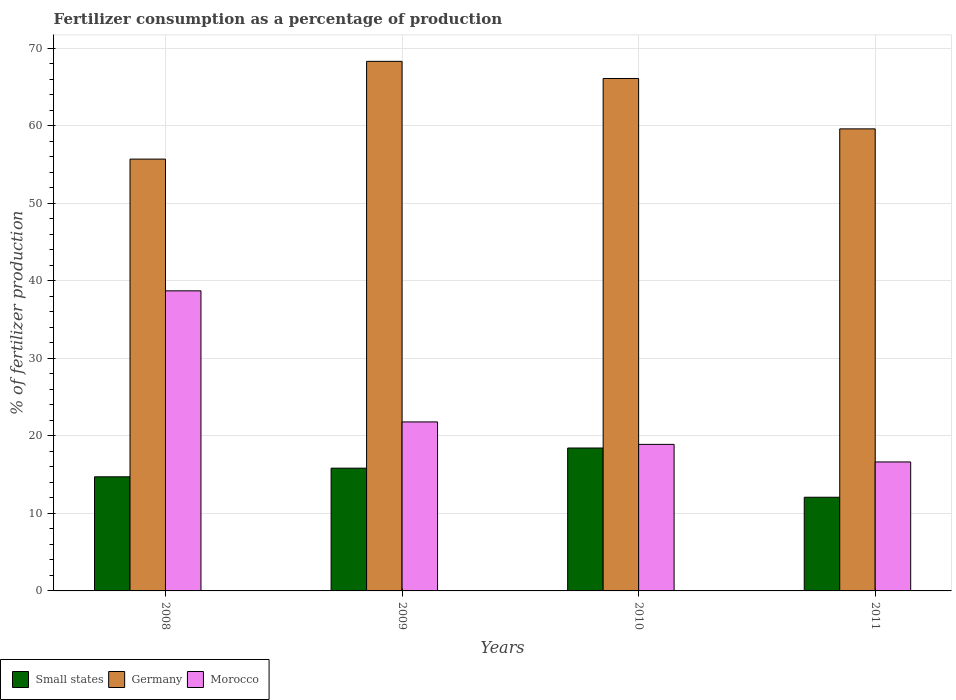Are the number of bars per tick equal to the number of legend labels?
Ensure brevity in your answer.  Yes. How many bars are there on the 4th tick from the left?
Your answer should be very brief. 3. What is the label of the 2nd group of bars from the left?
Your response must be concise. 2009. In how many cases, is the number of bars for a given year not equal to the number of legend labels?
Your response must be concise. 0. What is the percentage of fertilizers consumed in Germany in 2011?
Offer a very short reply. 59.58. Across all years, what is the maximum percentage of fertilizers consumed in Small states?
Keep it short and to the point. 18.43. Across all years, what is the minimum percentage of fertilizers consumed in Germany?
Give a very brief answer. 55.68. In which year was the percentage of fertilizers consumed in Morocco minimum?
Give a very brief answer. 2011. What is the total percentage of fertilizers consumed in Small states in the graph?
Keep it short and to the point. 61.05. What is the difference between the percentage of fertilizers consumed in Small states in 2009 and that in 2010?
Keep it short and to the point. -2.6. What is the difference between the percentage of fertilizers consumed in Morocco in 2008 and the percentage of fertilizers consumed in Germany in 2010?
Your answer should be compact. -27.38. What is the average percentage of fertilizers consumed in Morocco per year?
Your response must be concise. 24. In the year 2010, what is the difference between the percentage of fertilizers consumed in Germany and percentage of fertilizers consumed in Morocco?
Your answer should be compact. 47.18. In how many years, is the percentage of fertilizers consumed in Morocco greater than 44 %?
Offer a very short reply. 0. What is the ratio of the percentage of fertilizers consumed in Morocco in 2008 to that in 2011?
Offer a terse response. 2.33. Is the percentage of fertilizers consumed in Morocco in 2008 less than that in 2009?
Ensure brevity in your answer.  No. What is the difference between the highest and the second highest percentage of fertilizers consumed in Small states?
Keep it short and to the point. 2.6. What is the difference between the highest and the lowest percentage of fertilizers consumed in Morocco?
Make the answer very short. 22.06. In how many years, is the percentage of fertilizers consumed in Small states greater than the average percentage of fertilizers consumed in Small states taken over all years?
Your answer should be very brief. 2. What does the 3rd bar from the left in 2009 represents?
Offer a very short reply. Morocco. What does the 1st bar from the right in 2009 represents?
Your answer should be compact. Morocco. How many bars are there?
Provide a succinct answer. 12. What is the difference between two consecutive major ticks on the Y-axis?
Make the answer very short. 10. Are the values on the major ticks of Y-axis written in scientific E-notation?
Keep it short and to the point. No. How are the legend labels stacked?
Provide a short and direct response. Horizontal. What is the title of the graph?
Keep it short and to the point. Fertilizer consumption as a percentage of production. Does "Seychelles" appear as one of the legend labels in the graph?
Offer a terse response. No. What is the label or title of the X-axis?
Provide a short and direct response. Years. What is the label or title of the Y-axis?
Provide a succinct answer. % of fertilizer production. What is the % of fertilizer production of Small states in 2008?
Provide a short and direct response. 14.71. What is the % of fertilizer production in Germany in 2008?
Make the answer very short. 55.68. What is the % of fertilizer production in Morocco in 2008?
Your answer should be very brief. 38.69. What is the % of fertilizer production of Small states in 2009?
Your response must be concise. 15.83. What is the % of fertilizer production of Germany in 2009?
Provide a short and direct response. 68.28. What is the % of fertilizer production in Morocco in 2009?
Provide a short and direct response. 21.79. What is the % of fertilizer production in Small states in 2010?
Your answer should be very brief. 18.43. What is the % of fertilizer production of Germany in 2010?
Your response must be concise. 66.07. What is the % of fertilizer production in Morocco in 2010?
Your answer should be compact. 18.9. What is the % of fertilizer production of Small states in 2011?
Keep it short and to the point. 12.08. What is the % of fertilizer production in Germany in 2011?
Give a very brief answer. 59.58. What is the % of fertilizer production of Morocco in 2011?
Your answer should be very brief. 16.63. Across all years, what is the maximum % of fertilizer production of Small states?
Give a very brief answer. 18.43. Across all years, what is the maximum % of fertilizer production in Germany?
Provide a short and direct response. 68.28. Across all years, what is the maximum % of fertilizer production of Morocco?
Provide a short and direct response. 38.69. Across all years, what is the minimum % of fertilizer production of Small states?
Provide a succinct answer. 12.08. Across all years, what is the minimum % of fertilizer production of Germany?
Offer a very short reply. 55.68. Across all years, what is the minimum % of fertilizer production of Morocco?
Make the answer very short. 16.63. What is the total % of fertilizer production in Small states in the graph?
Provide a succinct answer. 61.05. What is the total % of fertilizer production of Germany in the graph?
Make the answer very short. 249.61. What is the total % of fertilizer production of Morocco in the graph?
Provide a succinct answer. 96.01. What is the difference between the % of fertilizer production of Small states in 2008 and that in 2009?
Make the answer very short. -1.11. What is the difference between the % of fertilizer production of Germany in 2008 and that in 2009?
Offer a terse response. -12.6. What is the difference between the % of fertilizer production in Morocco in 2008 and that in 2009?
Your answer should be very brief. 16.9. What is the difference between the % of fertilizer production of Small states in 2008 and that in 2010?
Offer a terse response. -3.71. What is the difference between the % of fertilizer production in Germany in 2008 and that in 2010?
Your response must be concise. -10.39. What is the difference between the % of fertilizer production in Morocco in 2008 and that in 2010?
Your answer should be very brief. 19.8. What is the difference between the % of fertilizer production in Small states in 2008 and that in 2011?
Your answer should be compact. 2.64. What is the difference between the % of fertilizer production of Germany in 2008 and that in 2011?
Your answer should be compact. -3.9. What is the difference between the % of fertilizer production of Morocco in 2008 and that in 2011?
Ensure brevity in your answer.  22.06. What is the difference between the % of fertilizer production in Small states in 2009 and that in 2010?
Your answer should be very brief. -2.6. What is the difference between the % of fertilizer production of Germany in 2009 and that in 2010?
Your answer should be compact. 2.21. What is the difference between the % of fertilizer production in Morocco in 2009 and that in 2010?
Give a very brief answer. 2.9. What is the difference between the % of fertilizer production in Small states in 2009 and that in 2011?
Provide a short and direct response. 3.75. What is the difference between the % of fertilizer production of Germany in 2009 and that in 2011?
Make the answer very short. 8.7. What is the difference between the % of fertilizer production in Morocco in 2009 and that in 2011?
Give a very brief answer. 5.16. What is the difference between the % of fertilizer production of Small states in 2010 and that in 2011?
Offer a very short reply. 6.35. What is the difference between the % of fertilizer production of Germany in 2010 and that in 2011?
Make the answer very short. 6.5. What is the difference between the % of fertilizer production in Morocco in 2010 and that in 2011?
Provide a short and direct response. 2.26. What is the difference between the % of fertilizer production in Small states in 2008 and the % of fertilizer production in Germany in 2009?
Provide a short and direct response. -53.57. What is the difference between the % of fertilizer production in Small states in 2008 and the % of fertilizer production in Morocco in 2009?
Make the answer very short. -7.08. What is the difference between the % of fertilizer production of Germany in 2008 and the % of fertilizer production of Morocco in 2009?
Provide a succinct answer. 33.89. What is the difference between the % of fertilizer production of Small states in 2008 and the % of fertilizer production of Germany in 2010?
Your answer should be very brief. -51.36. What is the difference between the % of fertilizer production in Small states in 2008 and the % of fertilizer production in Morocco in 2010?
Give a very brief answer. -4.18. What is the difference between the % of fertilizer production of Germany in 2008 and the % of fertilizer production of Morocco in 2010?
Your response must be concise. 36.78. What is the difference between the % of fertilizer production in Small states in 2008 and the % of fertilizer production in Germany in 2011?
Your answer should be very brief. -44.86. What is the difference between the % of fertilizer production in Small states in 2008 and the % of fertilizer production in Morocco in 2011?
Offer a very short reply. -1.92. What is the difference between the % of fertilizer production in Germany in 2008 and the % of fertilizer production in Morocco in 2011?
Give a very brief answer. 39.05. What is the difference between the % of fertilizer production of Small states in 2009 and the % of fertilizer production of Germany in 2010?
Offer a very short reply. -50.24. What is the difference between the % of fertilizer production of Small states in 2009 and the % of fertilizer production of Morocco in 2010?
Your answer should be very brief. -3.07. What is the difference between the % of fertilizer production in Germany in 2009 and the % of fertilizer production in Morocco in 2010?
Your answer should be very brief. 49.39. What is the difference between the % of fertilizer production in Small states in 2009 and the % of fertilizer production in Germany in 2011?
Offer a terse response. -43.75. What is the difference between the % of fertilizer production in Small states in 2009 and the % of fertilizer production in Morocco in 2011?
Your answer should be compact. -0.8. What is the difference between the % of fertilizer production in Germany in 2009 and the % of fertilizer production in Morocco in 2011?
Make the answer very short. 51.65. What is the difference between the % of fertilizer production of Small states in 2010 and the % of fertilizer production of Germany in 2011?
Provide a short and direct response. -41.15. What is the difference between the % of fertilizer production in Small states in 2010 and the % of fertilizer production in Morocco in 2011?
Make the answer very short. 1.8. What is the difference between the % of fertilizer production in Germany in 2010 and the % of fertilizer production in Morocco in 2011?
Your answer should be very brief. 49.44. What is the average % of fertilizer production in Small states per year?
Your answer should be very brief. 15.26. What is the average % of fertilizer production in Germany per year?
Keep it short and to the point. 62.4. What is the average % of fertilizer production of Morocco per year?
Ensure brevity in your answer.  24. In the year 2008, what is the difference between the % of fertilizer production of Small states and % of fertilizer production of Germany?
Make the answer very short. -40.96. In the year 2008, what is the difference between the % of fertilizer production of Small states and % of fertilizer production of Morocco?
Make the answer very short. -23.98. In the year 2008, what is the difference between the % of fertilizer production in Germany and % of fertilizer production in Morocco?
Your answer should be compact. 16.99. In the year 2009, what is the difference between the % of fertilizer production in Small states and % of fertilizer production in Germany?
Offer a very short reply. -52.45. In the year 2009, what is the difference between the % of fertilizer production in Small states and % of fertilizer production in Morocco?
Your answer should be very brief. -5.96. In the year 2009, what is the difference between the % of fertilizer production in Germany and % of fertilizer production in Morocco?
Your answer should be very brief. 46.49. In the year 2010, what is the difference between the % of fertilizer production of Small states and % of fertilizer production of Germany?
Give a very brief answer. -47.65. In the year 2010, what is the difference between the % of fertilizer production in Small states and % of fertilizer production in Morocco?
Your answer should be very brief. -0.47. In the year 2010, what is the difference between the % of fertilizer production in Germany and % of fertilizer production in Morocco?
Keep it short and to the point. 47.18. In the year 2011, what is the difference between the % of fertilizer production of Small states and % of fertilizer production of Germany?
Your response must be concise. -47.5. In the year 2011, what is the difference between the % of fertilizer production in Small states and % of fertilizer production in Morocco?
Your answer should be compact. -4.55. In the year 2011, what is the difference between the % of fertilizer production of Germany and % of fertilizer production of Morocco?
Provide a short and direct response. 42.95. What is the ratio of the % of fertilizer production in Small states in 2008 to that in 2009?
Your answer should be very brief. 0.93. What is the ratio of the % of fertilizer production of Germany in 2008 to that in 2009?
Your response must be concise. 0.82. What is the ratio of the % of fertilizer production in Morocco in 2008 to that in 2009?
Provide a short and direct response. 1.78. What is the ratio of the % of fertilizer production in Small states in 2008 to that in 2010?
Provide a succinct answer. 0.8. What is the ratio of the % of fertilizer production of Germany in 2008 to that in 2010?
Offer a very short reply. 0.84. What is the ratio of the % of fertilizer production of Morocco in 2008 to that in 2010?
Give a very brief answer. 2.05. What is the ratio of the % of fertilizer production of Small states in 2008 to that in 2011?
Give a very brief answer. 1.22. What is the ratio of the % of fertilizer production in Germany in 2008 to that in 2011?
Keep it short and to the point. 0.93. What is the ratio of the % of fertilizer production in Morocco in 2008 to that in 2011?
Your answer should be compact. 2.33. What is the ratio of the % of fertilizer production in Small states in 2009 to that in 2010?
Provide a short and direct response. 0.86. What is the ratio of the % of fertilizer production in Germany in 2009 to that in 2010?
Provide a succinct answer. 1.03. What is the ratio of the % of fertilizer production of Morocco in 2009 to that in 2010?
Ensure brevity in your answer.  1.15. What is the ratio of the % of fertilizer production in Small states in 2009 to that in 2011?
Keep it short and to the point. 1.31. What is the ratio of the % of fertilizer production in Germany in 2009 to that in 2011?
Offer a terse response. 1.15. What is the ratio of the % of fertilizer production of Morocco in 2009 to that in 2011?
Provide a short and direct response. 1.31. What is the ratio of the % of fertilizer production of Small states in 2010 to that in 2011?
Your response must be concise. 1.53. What is the ratio of the % of fertilizer production of Germany in 2010 to that in 2011?
Your answer should be very brief. 1.11. What is the ratio of the % of fertilizer production in Morocco in 2010 to that in 2011?
Your answer should be very brief. 1.14. What is the difference between the highest and the second highest % of fertilizer production of Small states?
Offer a very short reply. 2.6. What is the difference between the highest and the second highest % of fertilizer production of Germany?
Provide a short and direct response. 2.21. What is the difference between the highest and the second highest % of fertilizer production in Morocco?
Your response must be concise. 16.9. What is the difference between the highest and the lowest % of fertilizer production of Small states?
Your response must be concise. 6.35. What is the difference between the highest and the lowest % of fertilizer production in Germany?
Give a very brief answer. 12.6. What is the difference between the highest and the lowest % of fertilizer production of Morocco?
Make the answer very short. 22.06. 